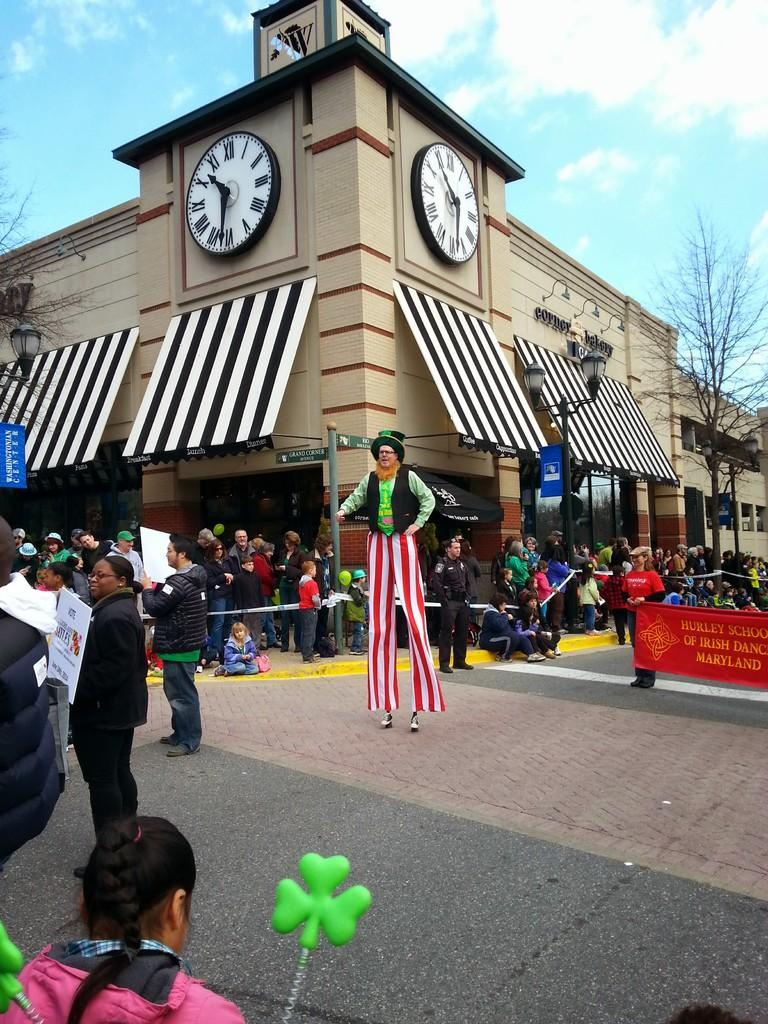<image>
Describe the image concisely. A parade takes place in town featuring the Hurley School of Irish Dance. 